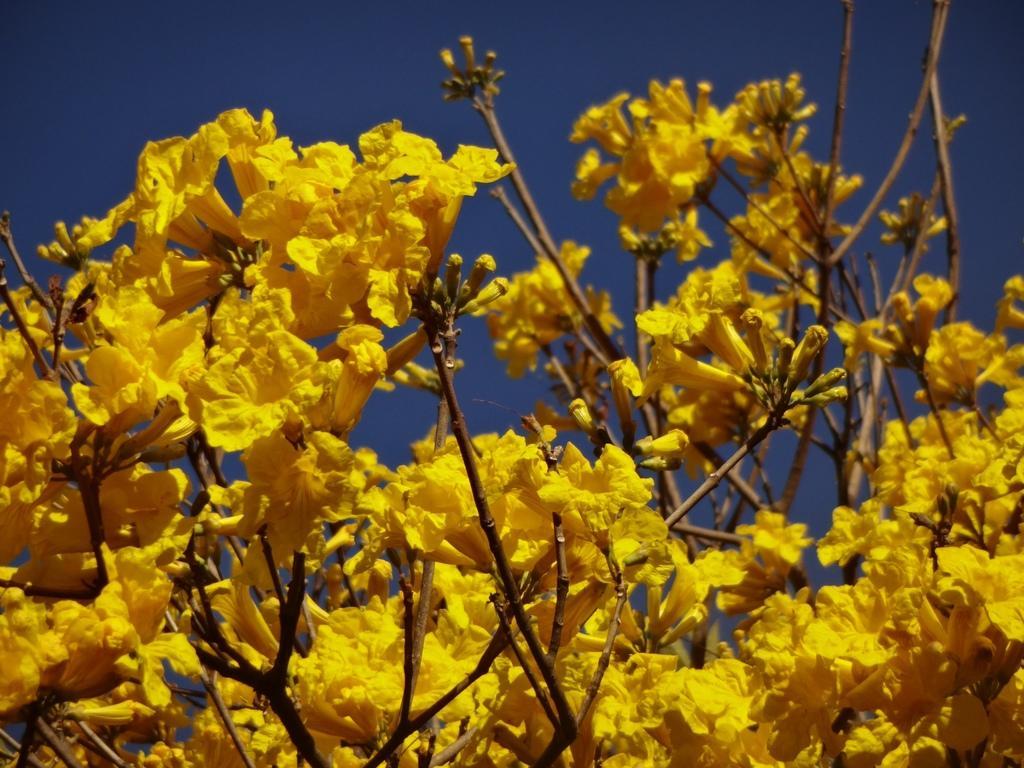How would you summarize this image in a sentence or two? In this image we can see yellow color flowers and stems. Behind sky is there. 